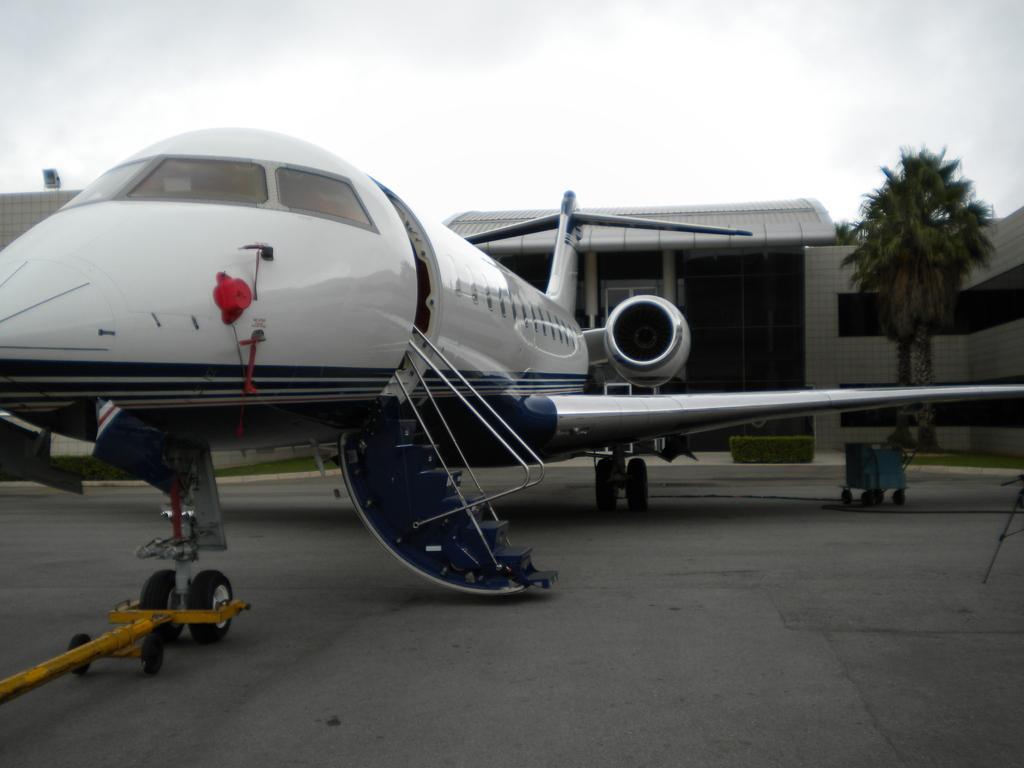Could you give a brief overview of what you see in this image? In this image there is an airplane on the road. There are trees on the grassland. Beside there are plants on the floor. Background there are buildings. Top of the image there is sky. Right side there is an object on the road. There is a metal rod attached to the tires of the airplane. 